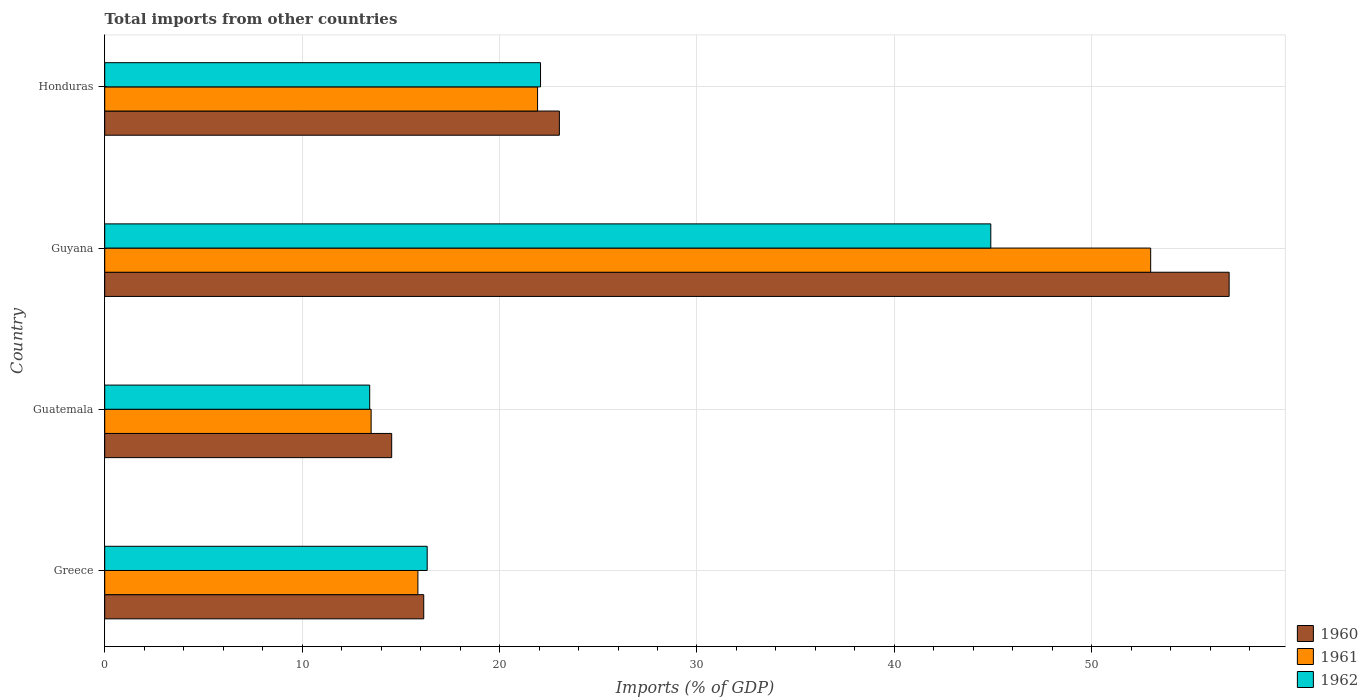How many different coloured bars are there?
Your answer should be compact. 3. How many groups of bars are there?
Provide a short and direct response. 4. How many bars are there on the 3rd tick from the top?
Make the answer very short. 3. How many bars are there on the 1st tick from the bottom?
Provide a short and direct response. 3. What is the label of the 1st group of bars from the top?
Your answer should be very brief. Honduras. What is the total imports in 1960 in Guyana?
Provide a succinct answer. 56.96. Across all countries, what is the maximum total imports in 1962?
Ensure brevity in your answer.  44.88. Across all countries, what is the minimum total imports in 1960?
Offer a terse response. 14.54. In which country was the total imports in 1962 maximum?
Provide a succinct answer. Guyana. In which country was the total imports in 1960 minimum?
Offer a very short reply. Guatemala. What is the total total imports in 1961 in the graph?
Keep it short and to the point. 104.27. What is the difference between the total imports in 1962 in Guatemala and that in Honduras?
Keep it short and to the point. -8.65. What is the difference between the total imports in 1961 in Guyana and the total imports in 1960 in Greece?
Provide a succinct answer. 36.82. What is the average total imports in 1960 per country?
Make the answer very short. 27.67. What is the difference between the total imports in 1960 and total imports in 1961 in Guyana?
Offer a very short reply. 3.98. In how many countries, is the total imports in 1961 greater than 42 %?
Offer a terse response. 1. What is the ratio of the total imports in 1960 in Greece to that in Honduras?
Ensure brevity in your answer.  0.7. What is the difference between the highest and the second highest total imports in 1960?
Offer a terse response. 33.93. What is the difference between the highest and the lowest total imports in 1962?
Give a very brief answer. 31.46. Is the sum of the total imports in 1960 in Guatemala and Honduras greater than the maximum total imports in 1962 across all countries?
Ensure brevity in your answer.  No. What does the 3rd bar from the bottom in Honduras represents?
Provide a short and direct response. 1962. How many countries are there in the graph?
Keep it short and to the point. 4. What is the difference between two consecutive major ticks on the X-axis?
Provide a succinct answer. 10. Are the values on the major ticks of X-axis written in scientific E-notation?
Offer a very short reply. No. Does the graph contain grids?
Offer a very short reply. Yes. Where does the legend appear in the graph?
Give a very brief answer. Bottom right. How many legend labels are there?
Your answer should be very brief. 3. What is the title of the graph?
Give a very brief answer. Total imports from other countries. What is the label or title of the X-axis?
Offer a very short reply. Imports (% of GDP). What is the Imports (% of GDP) of 1960 in Greece?
Offer a terse response. 16.16. What is the Imports (% of GDP) in 1961 in Greece?
Give a very brief answer. 15.86. What is the Imports (% of GDP) in 1962 in Greece?
Keep it short and to the point. 16.33. What is the Imports (% of GDP) of 1960 in Guatemala?
Your answer should be very brief. 14.54. What is the Imports (% of GDP) in 1961 in Guatemala?
Ensure brevity in your answer.  13.49. What is the Imports (% of GDP) in 1962 in Guatemala?
Offer a very short reply. 13.42. What is the Imports (% of GDP) of 1960 in Guyana?
Make the answer very short. 56.96. What is the Imports (% of GDP) in 1961 in Guyana?
Give a very brief answer. 52.98. What is the Imports (% of GDP) in 1962 in Guyana?
Make the answer very short. 44.88. What is the Imports (% of GDP) in 1960 in Honduras?
Your answer should be very brief. 23.03. What is the Imports (% of GDP) of 1961 in Honduras?
Your response must be concise. 21.93. What is the Imports (% of GDP) of 1962 in Honduras?
Ensure brevity in your answer.  22.08. Across all countries, what is the maximum Imports (% of GDP) in 1960?
Give a very brief answer. 56.96. Across all countries, what is the maximum Imports (% of GDP) in 1961?
Your response must be concise. 52.98. Across all countries, what is the maximum Imports (% of GDP) in 1962?
Offer a very short reply. 44.88. Across all countries, what is the minimum Imports (% of GDP) in 1960?
Provide a short and direct response. 14.54. Across all countries, what is the minimum Imports (% of GDP) of 1961?
Provide a short and direct response. 13.49. Across all countries, what is the minimum Imports (% of GDP) in 1962?
Offer a very short reply. 13.42. What is the total Imports (% of GDP) of 1960 in the graph?
Your answer should be compact. 110.68. What is the total Imports (% of GDP) of 1961 in the graph?
Your answer should be very brief. 104.27. What is the total Imports (% of GDP) of 1962 in the graph?
Offer a terse response. 96.72. What is the difference between the Imports (% of GDP) in 1960 in Greece and that in Guatemala?
Your answer should be compact. 1.62. What is the difference between the Imports (% of GDP) in 1961 in Greece and that in Guatemala?
Make the answer very short. 2.37. What is the difference between the Imports (% of GDP) in 1962 in Greece and that in Guatemala?
Offer a very short reply. 2.91. What is the difference between the Imports (% of GDP) of 1960 in Greece and that in Guyana?
Your answer should be very brief. -40.8. What is the difference between the Imports (% of GDP) in 1961 in Greece and that in Guyana?
Ensure brevity in your answer.  -37.12. What is the difference between the Imports (% of GDP) in 1962 in Greece and that in Guyana?
Offer a very short reply. -28.55. What is the difference between the Imports (% of GDP) in 1960 in Greece and that in Honduras?
Provide a short and direct response. -6.87. What is the difference between the Imports (% of GDP) of 1961 in Greece and that in Honduras?
Provide a short and direct response. -6.06. What is the difference between the Imports (% of GDP) of 1962 in Greece and that in Honduras?
Keep it short and to the point. -5.74. What is the difference between the Imports (% of GDP) of 1960 in Guatemala and that in Guyana?
Your response must be concise. -42.42. What is the difference between the Imports (% of GDP) of 1961 in Guatemala and that in Guyana?
Make the answer very short. -39.49. What is the difference between the Imports (% of GDP) in 1962 in Guatemala and that in Guyana?
Provide a succinct answer. -31.46. What is the difference between the Imports (% of GDP) in 1960 in Guatemala and that in Honduras?
Offer a terse response. -8.49. What is the difference between the Imports (% of GDP) in 1961 in Guatemala and that in Honduras?
Your answer should be compact. -8.43. What is the difference between the Imports (% of GDP) of 1962 in Guatemala and that in Honduras?
Provide a short and direct response. -8.65. What is the difference between the Imports (% of GDP) of 1960 in Guyana and that in Honduras?
Your answer should be very brief. 33.93. What is the difference between the Imports (% of GDP) of 1961 in Guyana and that in Honduras?
Your answer should be compact. 31.06. What is the difference between the Imports (% of GDP) in 1962 in Guyana and that in Honduras?
Provide a short and direct response. 22.81. What is the difference between the Imports (% of GDP) of 1960 in Greece and the Imports (% of GDP) of 1961 in Guatemala?
Your answer should be very brief. 2.66. What is the difference between the Imports (% of GDP) in 1960 in Greece and the Imports (% of GDP) in 1962 in Guatemala?
Offer a terse response. 2.74. What is the difference between the Imports (% of GDP) of 1961 in Greece and the Imports (% of GDP) of 1962 in Guatemala?
Give a very brief answer. 2.44. What is the difference between the Imports (% of GDP) of 1960 in Greece and the Imports (% of GDP) of 1961 in Guyana?
Keep it short and to the point. -36.82. What is the difference between the Imports (% of GDP) in 1960 in Greece and the Imports (% of GDP) in 1962 in Guyana?
Provide a succinct answer. -28.72. What is the difference between the Imports (% of GDP) of 1961 in Greece and the Imports (% of GDP) of 1962 in Guyana?
Give a very brief answer. -29.02. What is the difference between the Imports (% of GDP) in 1960 in Greece and the Imports (% of GDP) in 1961 in Honduras?
Your answer should be very brief. -5.77. What is the difference between the Imports (% of GDP) of 1960 in Greece and the Imports (% of GDP) of 1962 in Honduras?
Make the answer very short. -5.92. What is the difference between the Imports (% of GDP) in 1961 in Greece and the Imports (% of GDP) in 1962 in Honduras?
Provide a short and direct response. -6.21. What is the difference between the Imports (% of GDP) in 1960 in Guatemala and the Imports (% of GDP) in 1961 in Guyana?
Your answer should be very brief. -38.45. What is the difference between the Imports (% of GDP) in 1960 in Guatemala and the Imports (% of GDP) in 1962 in Guyana?
Provide a succinct answer. -30.35. What is the difference between the Imports (% of GDP) of 1961 in Guatemala and the Imports (% of GDP) of 1962 in Guyana?
Make the answer very short. -31.39. What is the difference between the Imports (% of GDP) in 1960 in Guatemala and the Imports (% of GDP) in 1961 in Honduras?
Your response must be concise. -7.39. What is the difference between the Imports (% of GDP) in 1960 in Guatemala and the Imports (% of GDP) in 1962 in Honduras?
Provide a short and direct response. -7.54. What is the difference between the Imports (% of GDP) in 1961 in Guatemala and the Imports (% of GDP) in 1962 in Honduras?
Provide a short and direct response. -8.58. What is the difference between the Imports (% of GDP) of 1960 in Guyana and the Imports (% of GDP) of 1961 in Honduras?
Provide a succinct answer. 35.03. What is the difference between the Imports (% of GDP) in 1960 in Guyana and the Imports (% of GDP) in 1962 in Honduras?
Make the answer very short. 34.88. What is the difference between the Imports (% of GDP) in 1961 in Guyana and the Imports (% of GDP) in 1962 in Honduras?
Your answer should be very brief. 30.91. What is the average Imports (% of GDP) in 1960 per country?
Give a very brief answer. 27.67. What is the average Imports (% of GDP) in 1961 per country?
Your answer should be compact. 26.07. What is the average Imports (% of GDP) of 1962 per country?
Provide a short and direct response. 24.18. What is the difference between the Imports (% of GDP) of 1960 and Imports (% of GDP) of 1961 in Greece?
Your answer should be very brief. 0.29. What is the difference between the Imports (% of GDP) of 1960 and Imports (% of GDP) of 1962 in Greece?
Offer a terse response. -0.18. What is the difference between the Imports (% of GDP) of 1961 and Imports (% of GDP) of 1962 in Greece?
Give a very brief answer. -0.47. What is the difference between the Imports (% of GDP) of 1960 and Imports (% of GDP) of 1961 in Guatemala?
Offer a terse response. 1.04. What is the difference between the Imports (% of GDP) of 1960 and Imports (% of GDP) of 1962 in Guatemala?
Keep it short and to the point. 1.11. What is the difference between the Imports (% of GDP) of 1961 and Imports (% of GDP) of 1962 in Guatemala?
Provide a succinct answer. 0.07. What is the difference between the Imports (% of GDP) of 1960 and Imports (% of GDP) of 1961 in Guyana?
Your response must be concise. 3.98. What is the difference between the Imports (% of GDP) in 1960 and Imports (% of GDP) in 1962 in Guyana?
Provide a short and direct response. 12.07. What is the difference between the Imports (% of GDP) of 1961 and Imports (% of GDP) of 1962 in Guyana?
Your response must be concise. 8.1. What is the difference between the Imports (% of GDP) of 1960 and Imports (% of GDP) of 1961 in Honduras?
Offer a terse response. 1.1. What is the difference between the Imports (% of GDP) in 1960 and Imports (% of GDP) in 1962 in Honduras?
Give a very brief answer. 0.95. What is the difference between the Imports (% of GDP) in 1961 and Imports (% of GDP) in 1962 in Honduras?
Ensure brevity in your answer.  -0.15. What is the ratio of the Imports (% of GDP) of 1960 in Greece to that in Guatemala?
Provide a succinct answer. 1.11. What is the ratio of the Imports (% of GDP) of 1961 in Greece to that in Guatemala?
Offer a very short reply. 1.18. What is the ratio of the Imports (% of GDP) in 1962 in Greece to that in Guatemala?
Give a very brief answer. 1.22. What is the ratio of the Imports (% of GDP) in 1960 in Greece to that in Guyana?
Your answer should be compact. 0.28. What is the ratio of the Imports (% of GDP) of 1961 in Greece to that in Guyana?
Make the answer very short. 0.3. What is the ratio of the Imports (% of GDP) of 1962 in Greece to that in Guyana?
Give a very brief answer. 0.36. What is the ratio of the Imports (% of GDP) of 1960 in Greece to that in Honduras?
Provide a short and direct response. 0.7. What is the ratio of the Imports (% of GDP) in 1961 in Greece to that in Honduras?
Offer a very short reply. 0.72. What is the ratio of the Imports (% of GDP) in 1962 in Greece to that in Honduras?
Your response must be concise. 0.74. What is the ratio of the Imports (% of GDP) of 1960 in Guatemala to that in Guyana?
Ensure brevity in your answer.  0.26. What is the ratio of the Imports (% of GDP) in 1961 in Guatemala to that in Guyana?
Make the answer very short. 0.25. What is the ratio of the Imports (% of GDP) of 1962 in Guatemala to that in Guyana?
Provide a short and direct response. 0.3. What is the ratio of the Imports (% of GDP) in 1960 in Guatemala to that in Honduras?
Make the answer very short. 0.63. What is the ratio of the Imports (% of GDP) of 1961 in Guatemala to that in Honduras?
Your answer should be compact. 0.62. What is the ratio of the Imports (% of GDP) of 1962 in Guatemala to that in Honduras?
Your answer should be compact. 0.61. What is the ratio of the Imports (% of GDP) in 1960 in Guyana to that in Honduras?
Make the answer very short. 2.47. What is the ratio of the Imports (% of GDP) of 1961 in Guyana to that in Honduras?
Your answer should be very brief. 2.42. What is the ratio of the Imports (% of GDP) in 1962 in Guyana to that in Honduras?
Your response must be concise. 2.03. What is the difference between the highest and the second highest Imports (% of GDP) in 1960?
Provide a short and direct response. 33.93. What is the difference between the highest and the second highest Imports (% of GDP) of 1961?
Make the answer very short. 31.06. What is the difference between the highest and the second highest Imports (% of GDP) of 1962?
Your response must be concise. 22.81. What is the difference between the highest and the lowest Imports (% of GDP) of 1960?
Your answer should be very brief. 42.42. What is the difference between the highest and the lowest Imports (% of GDP) of 1961?
Make the answer very short. 39.49. What is the difference between the highest and the lowest Imports (% of GDP) of 1962?
Keep it short and to the point. 31.46. 